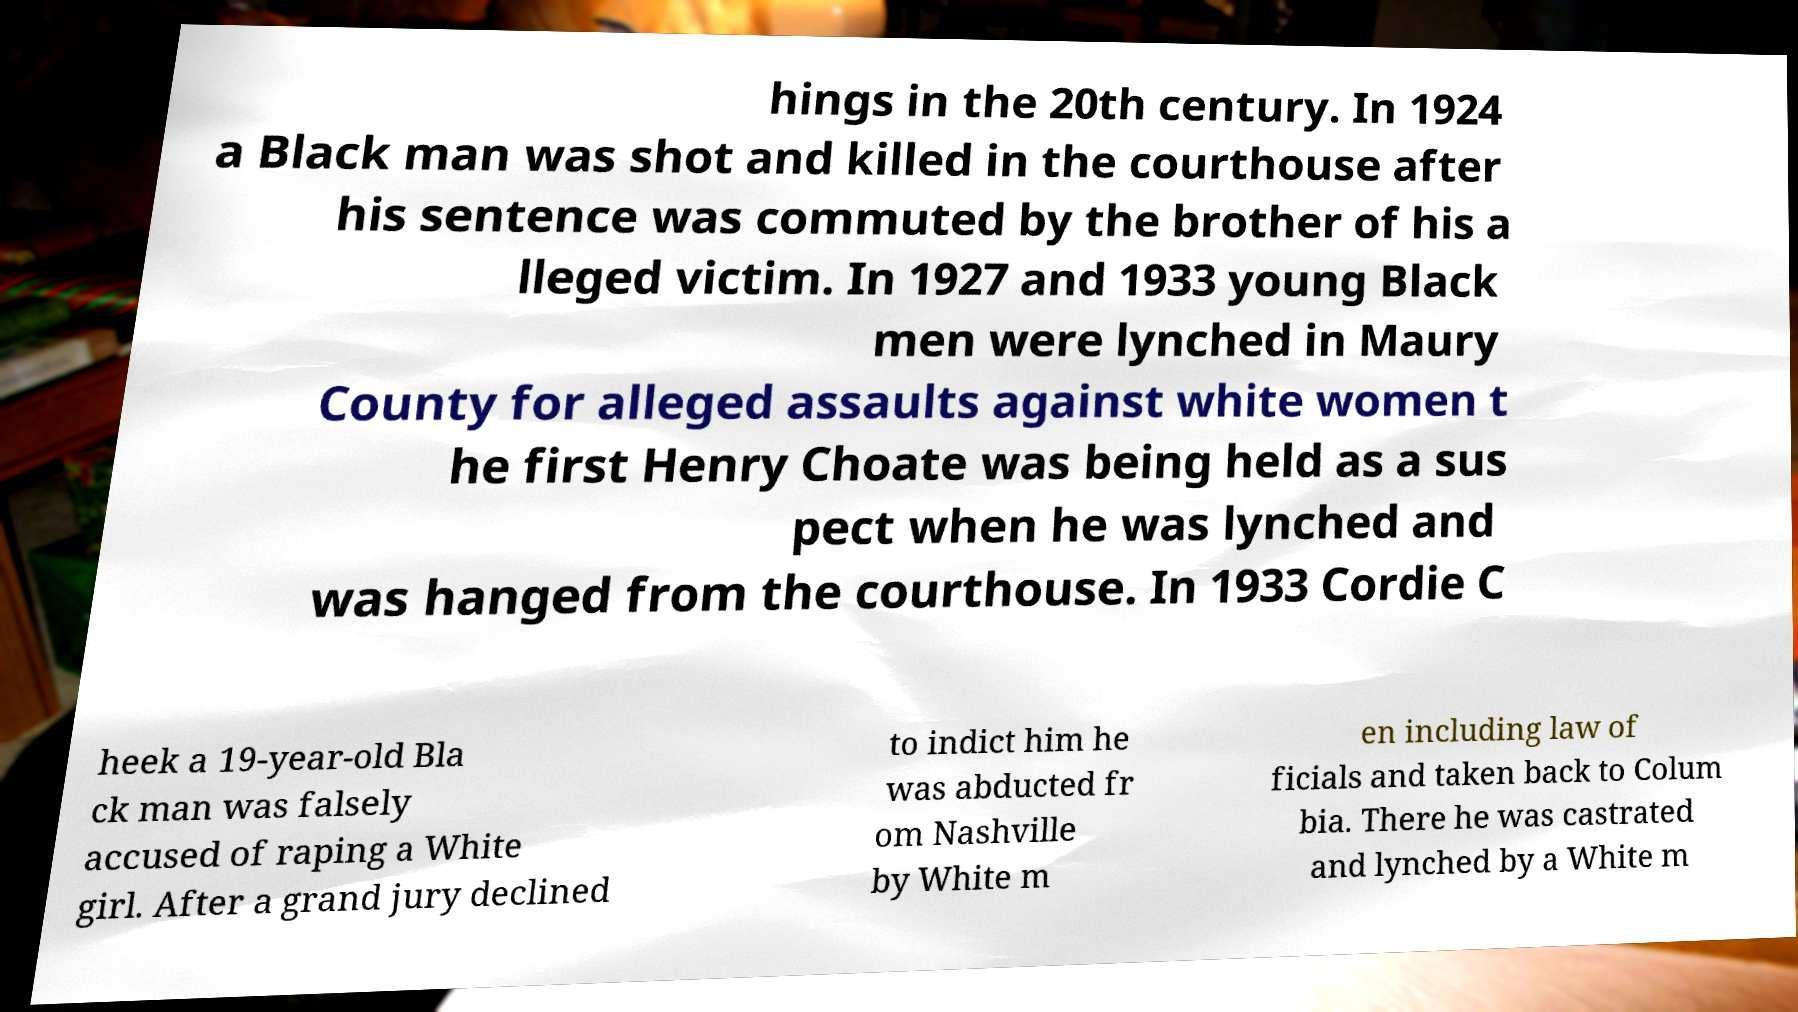Could you assist in decoding the text presented in this image and type it out clearly? hings in the 20th century. In 1924 a Black man was shot and killed in the courthouse after his sentence was commuted by the brother of his a lleged victim. In 1927 and 1933 young Black men were lynched in Maury County for alleged assaults against white women t he first Henry Choate was being held as a sus pect when he was lynched and was hanged from the courthouse. In 1933 Cordie C heek a 19-year-old Bla ck man was falsely accused of raping a White girl. After a grand jury declined to indict him he was abducted fr om Nashville by White m en including law of ficials and taken back to Colum bia. There he was castrated and lynched by a White m 